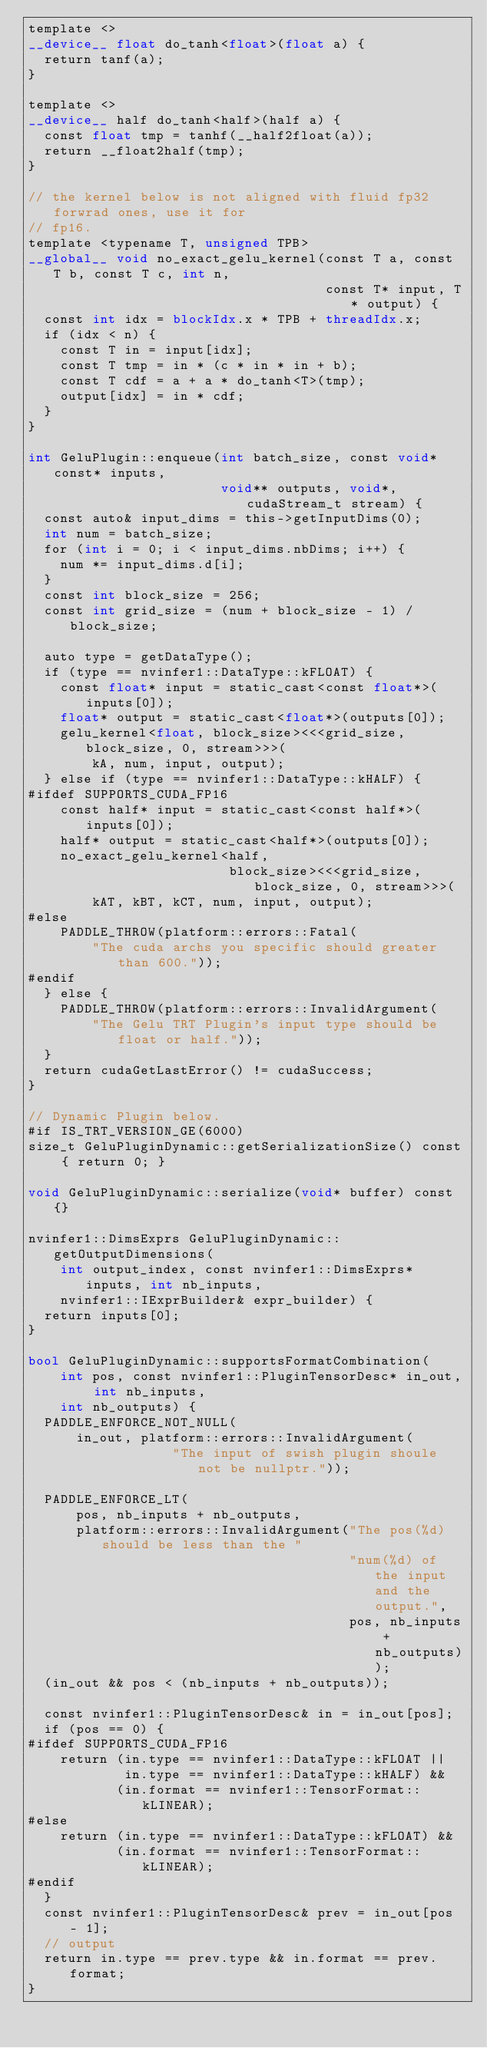Convert code to text. <code><loc_0><loc_0><loc_500><loc_500><_Cuda_>template <>
__device__ float do_tanh<float>(float a) {
  return tanf(a);
}

template <>
__device__ half do_tanh<half>(half a) {
  const float tmp = tanhf(__half2float(a));
  return __float2half(tmp);
}

// the kernel below is not aligned with fluid fp32 forwrad ones, use it for
// fp16.
template <typename T, unsigned TPB>
__global__ void no_exact_gelu_kernel(const T a, const T b, const T c, int n,
                                     const T* input, T* output) {
  const int idx = blockIdx.x * TPB + threadIdx.x;
  if (idx < n) {
    const T in = input[idx];
    const T tmp = in * (c * in * in + b);
    const T cdf = a + a * do_tanh<T>(tmp);
    output[idx] = in * cdf;
  }
}

int GeluPlugin::enqueue(int batch_size, const void* const* inputs,
                        void** outputs, void*, cudaStream_t stream) {
  const auto& input_dims = this->getInputDims(0);
  int num = batch_size;
  for (int i = 0; i < input_dims.nbDims; i++) {
    num *= input_dims.d[i];
  }
  const int block_size = 256;
  const int grid_size = (num + block_size - 1) / block_size;

  auto type = getDataType();
  if (type == nvinfer1::DataType::kFLOAT) {
    const float* input = static_cast<const float*>(inputs[0]);
    float* output = static_cast<float*>(outputs[0]);
    gelu_kernel<float, block_size><<<grid_size, block_size, 0, stream>>>(
        kA, num, input, output);
  } else if (type == nvinfer1::DataType::kHALF) {
#ifdef SUPPORTS_CUDA_FP16
    const half* input = static_cast<const half*>(inputs[0]);
    half* output = static_cast<half*>(outputs[0]);
    no_exact_gelu_kernel<half,
                         block_size><<<grid_size, block_size, 0, stream>>>(
        kAT, kBT, kCT, num, input, output);
#else
    PADDLE_THROW(platform::errors::Fatal(
        "The cuda archs you specific should greater than 600."));
#endif
  } else {
    PADDLE_THROW(platform::errors::InvalidArgument(
        "The Gelu TRT Plugin's input type should be float or half."));
  }
  return cudaGetLastError() != cudaSuccess;
}

// Dynamic Plugin below.
#if IS_TRT_VERSION_GE(6000)
size_t GeluPluginDynamic::getSerializationSize() const { return 0; }

void GeluPluginDynamic::serialize(void* buffer) const {}

nvinfer1::DimsExprs GeluPluginDynamic::getOutputDimensions(
    int output_index, const nvinfer1::DimsExprs* inputs, int nb_inputs,
    nvinfer1::IExprBuilder& expr_builder) {
  return inputs[0];
}

bool GeluPluginDynamic::supportsFormatCombination(
    int pos, const nvinfer1::PluginTensorDesc* in_out, int nb_inputs,
    int nb_outputs) {
  PADDLE_ENFORCE_NOT_NULL(
      in_out, platform::errors::InvalidArgument(
                  "The input of swish plugin shoule not be nullptr."));

  PADDLE_ENFORCE_LT(
      pos, nb_inputs + nb_outputs,
      platform::errors::InvalidArgument("The pos(%d) should be less than the "
                                        "num(%d) of the input and the output.",
                                        pos, nb_inputs + nb_outputs));
  (in_out && pos < (nb_inputs + nb_outputs));

  const nvinfer1::PluginTensorDesc& in = in_out[pos];
  if (pos == 0) {
#ifdef SUPPORTS_CUDA_FP16
    return (in.type == nvinfer1::DataType::kFLOAT ||
            in.type == nvinfer1::DataType::kHALF) &&
           (in.format == nvinfer1::TensorFormat::kLINEAR);
#else
    return (in.type == nvinfer1::DataType::kFLOAT) &&
           (in.format == nvinfer1::TensorFormat::kLINEAR);
#endif
  }
  const nvinfer1::PluginTensorDesc& prev = in_out[pos - 1];
  // output
  return in.type == prev.type && in.format == prev.format;
}
</code> 